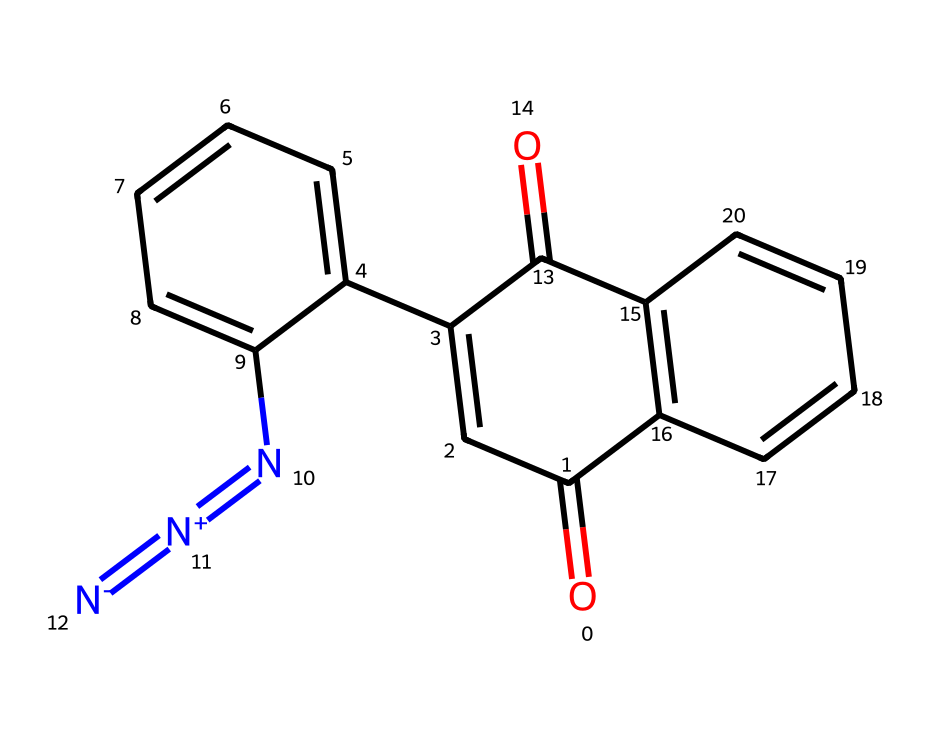What is the total number of carbon atoms in this photoresist monomer? Counting the carbon atoms in the provided SMILES notation gives us a total of 16 carbon atoms.
Answer: 16 What functional group is present in this chemical structure? The presence of the carbonyl group (C=O) indicates that this chemical has a ketone functional group, which can be recognized by the double bond of carbon to oxygen.
Answer: carbonyl How many nitrogen atoms are in the structure? By scanning the SMILES representation, we can identify 3 nitrogen atoms included in the structure, as evidenced by the "N" notations.
Answer: 3 Which component of the chemical contributes to its UV-sensitivity? The presence of the diazene group (N=[N+]=[N-]) provides UV-sensitivity characteristics, as it can undergo photochemical reactions upon exposure to UV light.
Answer: diazene group How many aromatic rings are present in the structure? The structure contains 2 distinct aromatic rings, which are indicated by the alternating double bonds within the hexagonal cycles in the representation.
Answer: 2 What type of polymerization mechanism can be utilized with this photoresist? The structure allows for radical polymerization, particularly due to the sensitivity to UV light, leading to cross-linking reactions which are common in photoresist applications.
Answer: radical polymerization What characteristic gives this chemical its application in blueprint printing? The combination of its UV sensitivity and ability to form cross-linked structures upon exposure to light makes it suitable for blueprint printing as it can provide high-resolution patterns.
Answer: UV sensitivity 